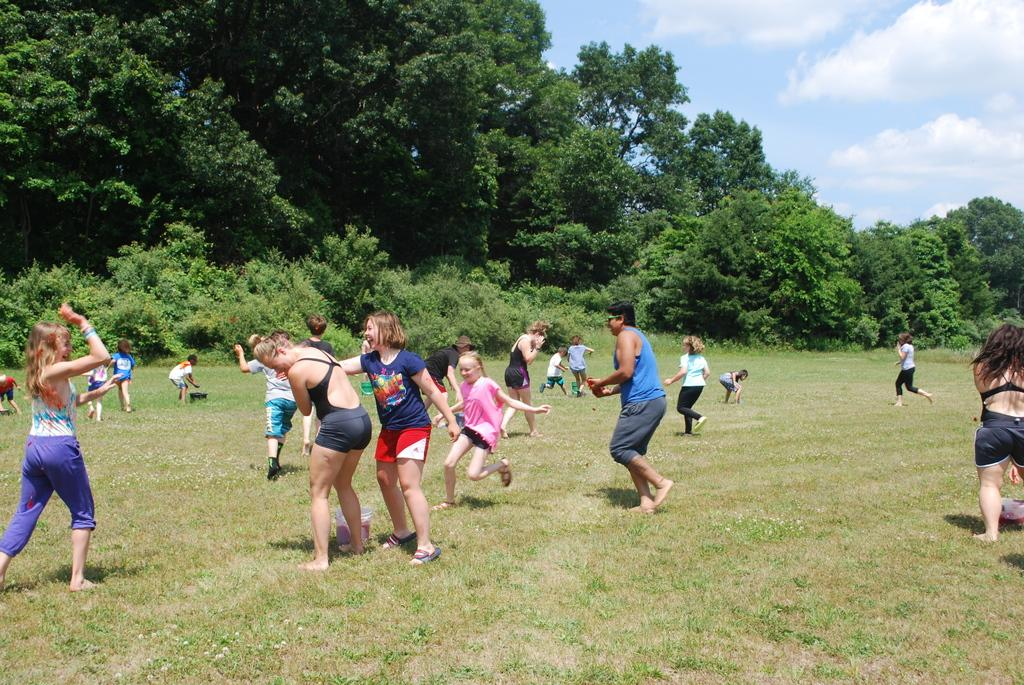How many people are in the image? There are people in the image, but the exact number is not specified. What are some of the people doing in the image? Some people are standing, and some are running on the ground. What can be seen in the background of the image? There are plants, grass, and the sky visible in the background of the image. What type of bomb can be seen in the image? There is no bomb present in the image. Can you tell me which berry is being picked by the people in the image? There is no berry-picking activity depicted in the image. 